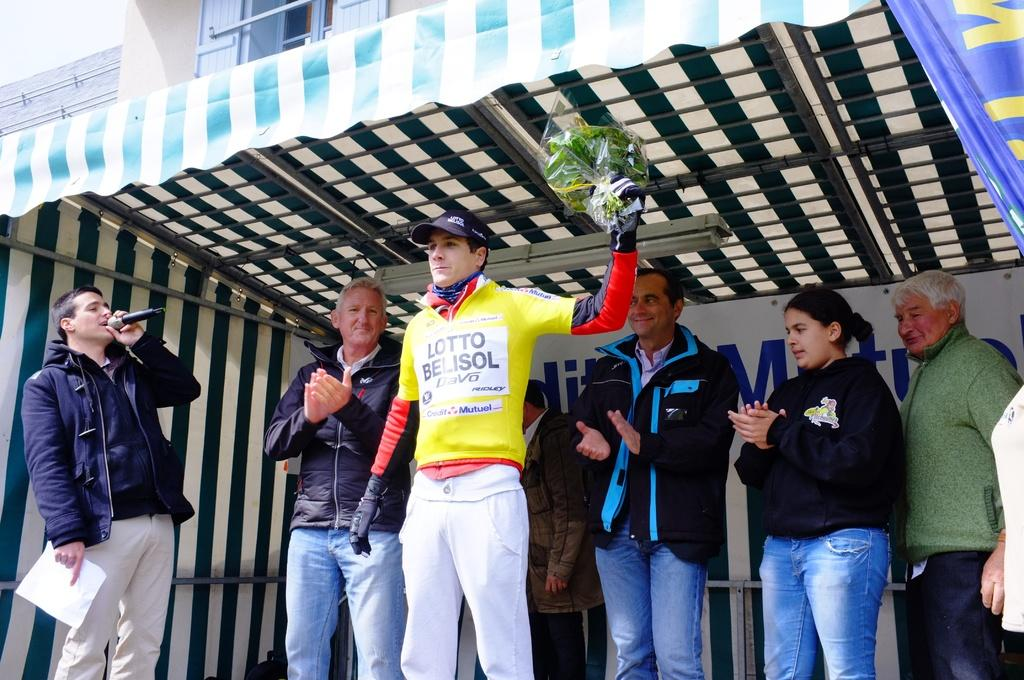What is the man in the center of the image holding? The man is holding a bouquet in the center of the image. What can be seen in the background of the image? There is a tent and other people in the background of the image. What structure is visible at the top of the image? There is a building visible at the top of the image. How many houses are visible in the image? There is no house visible in the image; only a tent, other people, and a building are present. What is the distance between the man and the building in the image? The distance between the man and the building cannot be determined from the image alone, as there is no reference point for scale. 